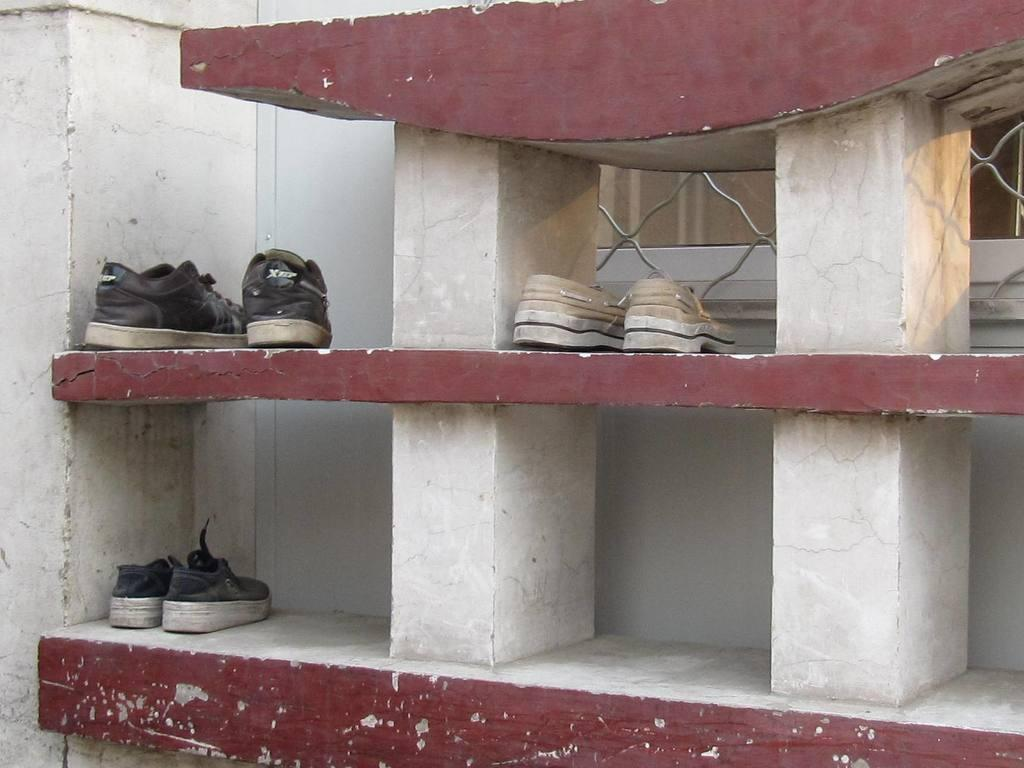How many pairs of shoes are visible in the image? There are three pairs of shoes in the image. How are the pairs of shoes arranged in the image? Each pair of shoes is arranged on an individual shelf. What type of van is parked in front of the shoes in the image? There is no van present in the image; it only features three pairs of shoes arranged on shelves. 